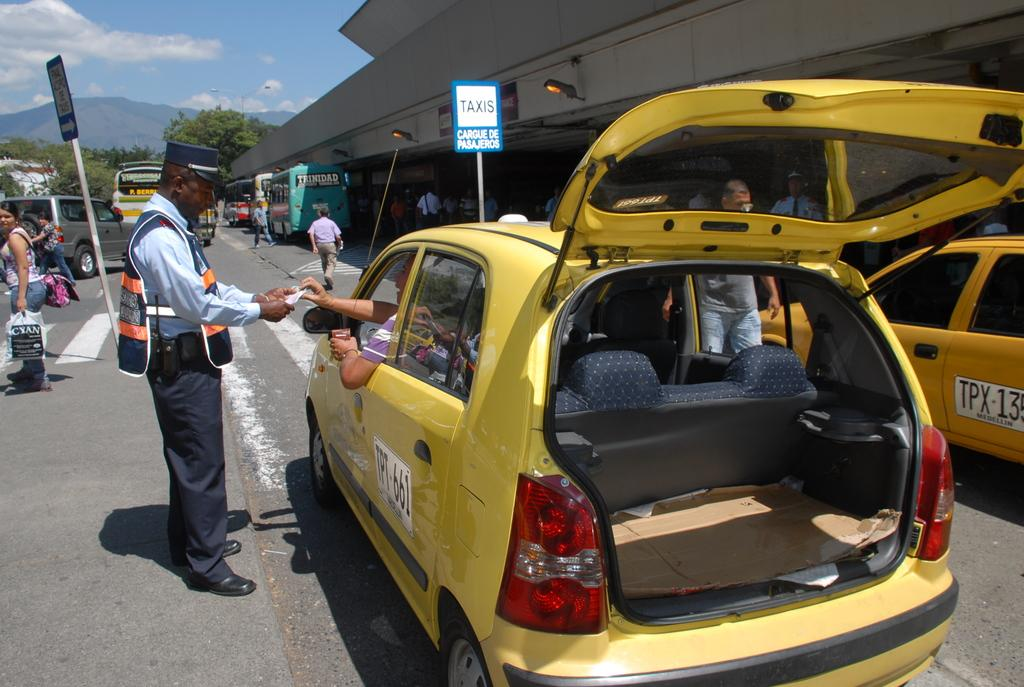<image>
Write a terse but informative summary of the picture. Two yellow taxis infront of a sign with the word TAXIS on it 